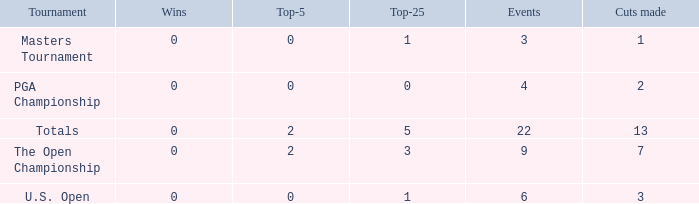What is the fewest number of top-25s for events with more than 13 cuts made? None. 